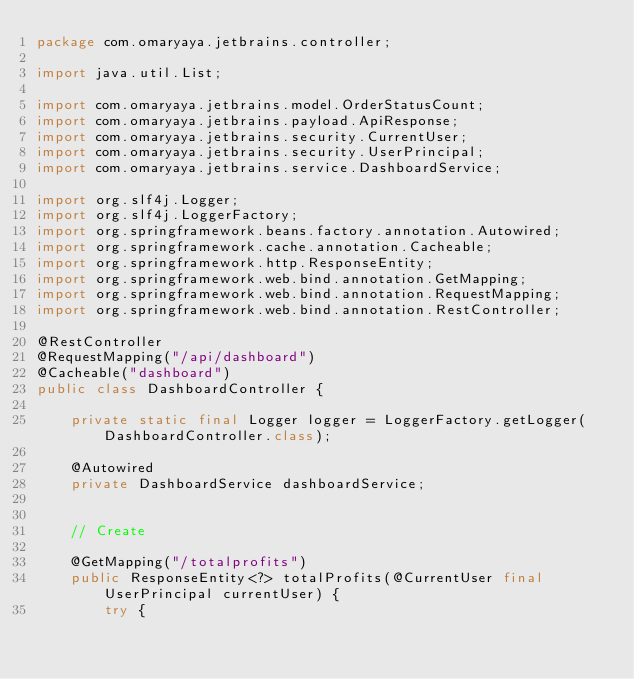Convert code to text. <code><loc_0><loc_0><loc_500><loc_500><_Java_>package com.omaryaya.jetbrains.controller;

import java.util.List;

import com.omaryaya.jetbrains.model.OrderStatusCount;
import com.omaryaya.jetbrains.payload.ApiResponse;
import com.omaryaya.jetbrains.security.CurrentUser;
import com.omaryaya.jetbrains.security.UserPrincipal;
import com.omaryaya.jetbrains.service.DashboardService;

import org.slf4j.Logger;
import org.slf4j.LoggerFactory;
import org.springframework.beans.factory.annotation.Autowired;
import org.springframework.cache.annotation.Cacheable;
import org.springframework.http.ResponseEntity;
import org.springframework.web.bind.annotation.GetMapping;
import org.springframework.web.bind.annotation.RequestMapping;
import org.springframework.web.bind.annotation.RestController;

@RestController
@RequestMapping("/api/dashboard")
@Cacheable("dashboard")
public class DashboardController {

    private static final Logger logger = LoggerFactory.getLogger(DashboardController.class);

    @Autowired
    private DashboardService dashboardService;

    
    // Create

    @GetMapping("/totalprofits")
    public ResponseEntity<?> totalProfits(@CurrentUser final UserPrincipal currentUser) {
        try {
</code> 